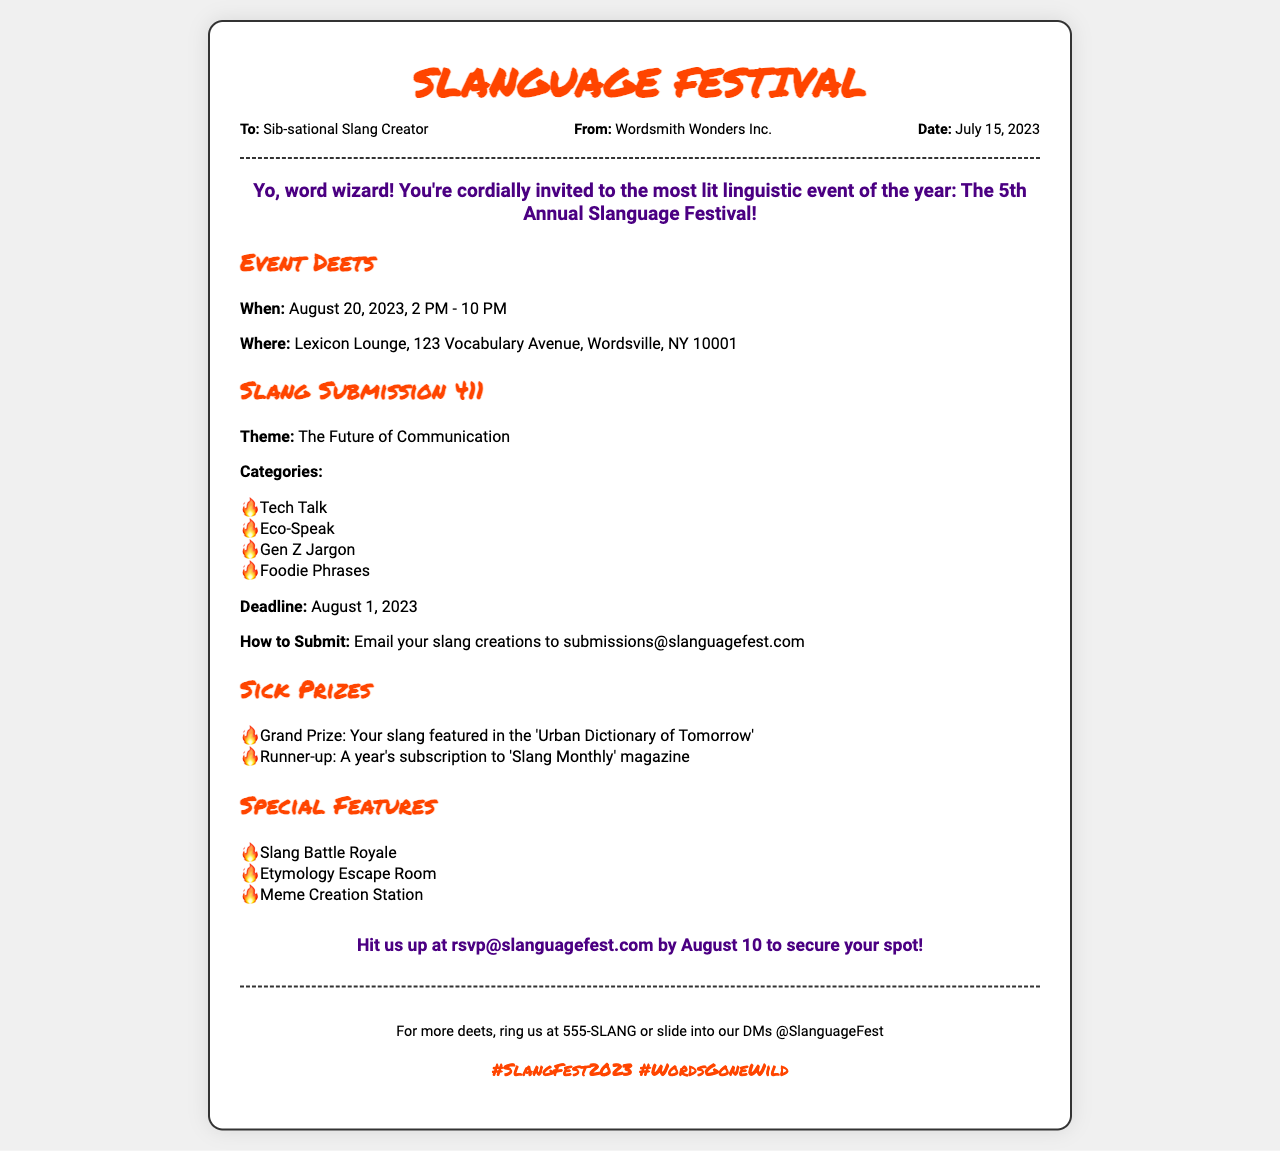What is the date of the festival? The date of the festival is explicitly mentioned in the event details section of the document.
Answer: August 20, 2023 Who is hosting the event? The sender's name at the top of the document indicates who is hosting the event.
Answer: Wordsmith Wonders Inc What is the submission deadline for slang creations? The deadline for submitting slang creations is specified in the slang submission section of the document.
Answer: August 1, 2023 What is the grand prize for the slang submissions? The grand prize description can be found in the prizes section of the document.
Answer: Your slang featured in the 'Urban Dictionary of Tomorrow' What is the theme of the festival? The theme is directly stated in the slang submission section of the document.
Answer: The Future of Communication What is the location of the festival? The location is provided in the event details section of the document.
Answer: Lexicon Lounge, 123 Vocabulary Avenue, Wordsville, NY 10001 What is the contact email for RSVPs? The RSVP contact information is clearly stated in the document.
Answer: rsvp@slanguagefest.com How many categories are there for slang submissions? The categories listed provide insight into the number of options for submissions.
Answer: Four What special feature involves competition? The special features section mentions an event related to competition among attendees.
Answer: Slang Battle Royale What is one way to find more details about the festival? The footer section outlines a method for obtaining further information about the event.
Answer: Ring us at 555-SLANG 